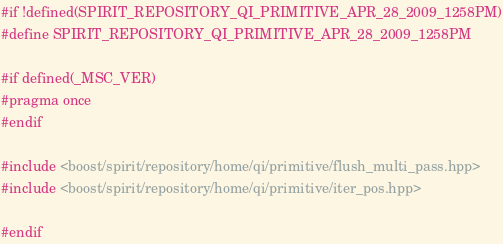Convert code to text. <code><loc_0><loc_0><loc_500><loc_500><_C++_>#if !defined(SPIRIT_REPOSITORY_QI_PRIMITIVE_APR_28_2009_1258PM)
#define SPIRIT_REPOSITORY_QI_PRIMITIVE_APR_28_2009_1258PM

#if defined(_MSC_VER)
#pragma once
#endif

#include <boost/spirit/repository/home/qi/primitive/flush_multi_pass.hpp>
#include <boost/spirit/repository/home/qi/primitive/iter_pos.hpp>

#endif

</code> 